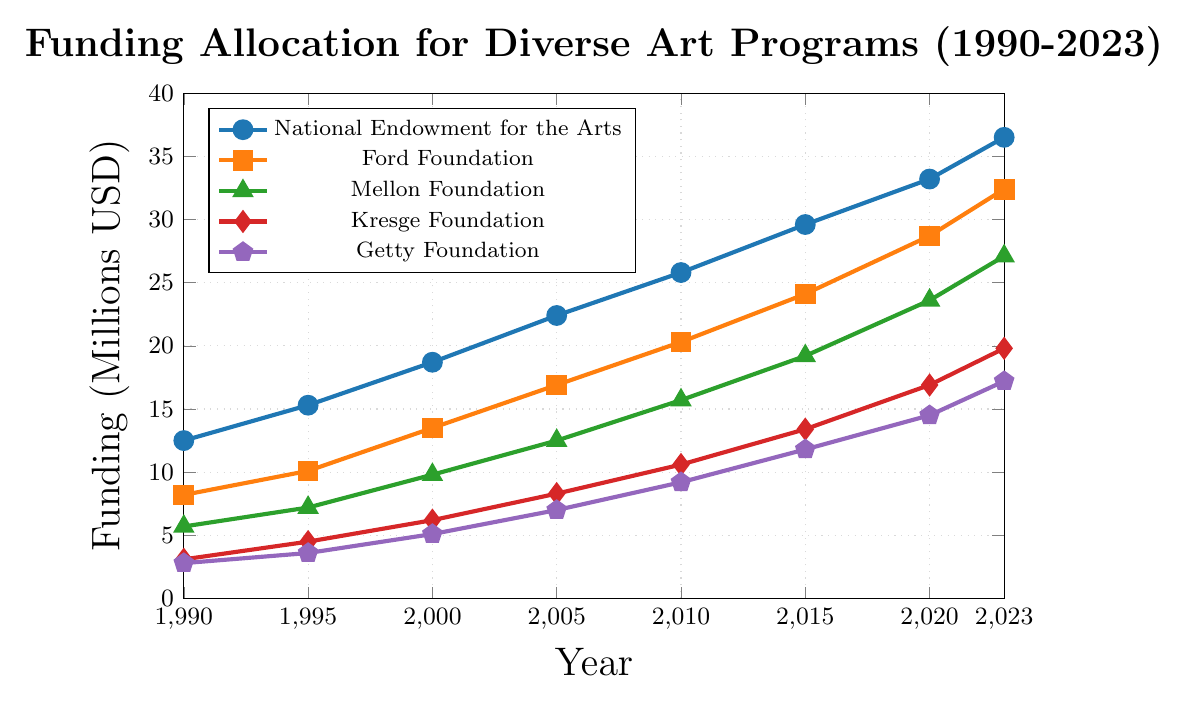What was the funding allocation by the National Endowment for the Arts (NEA) in 2005? Look at the value corresponding to the National Endowment for the Arts line in the year 2005. The point is at 22.4 million USD.
Answer: 22.4 million USD Compare the funding allocation between the Ford Foundation and the Mellon Foundation in 2023. Find the values for both foundations in 2023. The Ford Foundation has a value of 32.4 million USD, while the Mellon Foundation has 27.1 million USD. The Ford Foundation's funding is higher.
Answer: The Ford Foundation's funding is higher What is the difference in funding between the Kresge Foundation in 2010 and 2023? Locate the Kresge Foundation's values in 2010 and 2023. In 2010, it's 10.6 million USD, and in 2023, it's 19.8 million USD. Subtract the 2010 value from the 2023 value: 19.8 - 10.6 = 9.2 million USD.
Answer: 9.2 million USD Which foundation had the lowest funding allocation in 1990, and what was the amount? Look at all the foundations' values for 1990. The lowest value is for the Getty Foundation, which is 2.8 million USD.
Answer: Getty Foundation, 2.8 million USD Calculate the average funding for the Mellon Foundation from 1990 to 2023. Add up the Mellon Foundation's values for all years and divide by the number of years: (5.7 + 7.2 + 9.8 + 12.5 + 15.7 + 19.2 + 23.6 + 27.1) / 8 = 15.1 million USD.
Answer: 15.1 million USD In which year did the Ford Foundation's funding surpass 20 million USD, and by how much? Find the first year where the Ford Foundation's value exceeds 20 million USD. In 2010, it exceeds 20 million USD at 20.3 million USD. The amount surpassed is 0.3 million USD.
Answer: 2010, by 0.3 million USD What is the total funding allocation for the National Endowment for the Arts and the Kresge Foundation in 2020? Sum the 2020 values for both foundations: 33.2 million USD (NEA) + 16.9 million USD (Kresge) = 50.1 million USD.
Answer: 50.1 million USD How consistent has been the growth in funding for the Getty Foundation from 1990 to 2023? Observe the values for the Getty Foundation across the years. The funding increases steadily: (2.8, 3.6, 5.1, 7.0, 9.2, 11.8, 14.5, 17.2). Each step shows an increase, indicating consistent growth.
Answer: Consistent growth Compare the rate of increase between the National Endowment for the Arts and the Ford Foundation from 1990 to 2023. Calculate the increase for both foundations over the period. NEA: 36.5 - 12.5 = 24 million USD. Ford: 32.4 - 8.2 = 24.2 million USD. The Ford Foundation has a slightly higher rate of increase.
Answer: Ford Foundation has a higher rate By what factor did the Mellon Foundation's funding grow from 1990 to 2023? Divide the 2023 value by the 1990 value for Mellon Foundation: 27.1 / 5.7 ≈ 4.75.
Answer: Approximately 4.75 